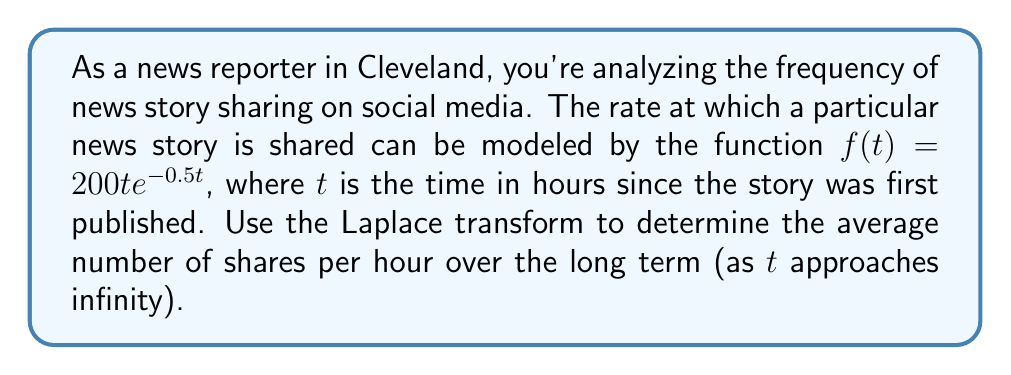Solve this math problem. To solve this problem, we'll follow these steps:

1) First, recall that the Laplace transform of $f(t)$ is defined as:

   $$F(s) = \int_0^\infty f(t)e^{-st} dt$$

2) In this case, $f(t) = 200te^{-0.5t}$, so we need to compute:

   $$F(s) = \int_0^\infty 200te^{-0.5t}e^{-st} dt = 200\int_0^\infty te^{-(s+0.5)t} dt$$

3) This integral can be solved using integration by parts. Let $u = t$ and $dv = e^{-(s+0.5)t}dt$. Then $du = dt$ and $v = -\frac{1}{s+0.5}e^{-(s+0.5)t}$. Applying integration by parts:

   $$F(s) = 200\left[-\frac{t}{s+0.5}e^{-(s+0.5)t}\right]_0^\infty + 200\int_0^\infty \frac{1}{s+0.5}e^{-(s+0.5)t} dt$$

4) The first term evaluates to zero at both limits. For the second term:

   $$F(s) = 200 \cdot \frac{1}{s+0.5} \cdot \left[-\frac{1}{s+0.5}e^{-(s+0.5)t}\right]_0^\infty = \frac{200}{(s+0.5)^2}$$

5) To find the average number of shares per hour over the long term, we can use the Final Value Theorem. This theorem states that:

   $$\lim_{t \to \infty} f(t) = \lim_{s \to 0} sF(s)$$

6) Applying this to our function:

   $$\lim_{t \to \infty} f(t) = \lim_{s \to 0} s \cdot \frac{200}{(s+0.5)^2} = \lim_{s \to 0} \frac{200s}{(s+0.5)^2}$$

7) Evaluating this limit:

   $$\lim_{s \to 0} \frac{200s}{(s+0.5)^2} = \frac{200 \cdot 0}{(0+0.5)^2} = 0$$

This result indicates that the number of shares approaches zero as time goes to infinity, which makes sense as the sharing rate would naturally decrease over time.
Answer: The average number of shares per hour over the long term (as $t$ approaches infinity) is 0. 